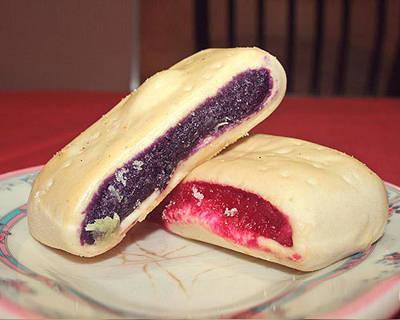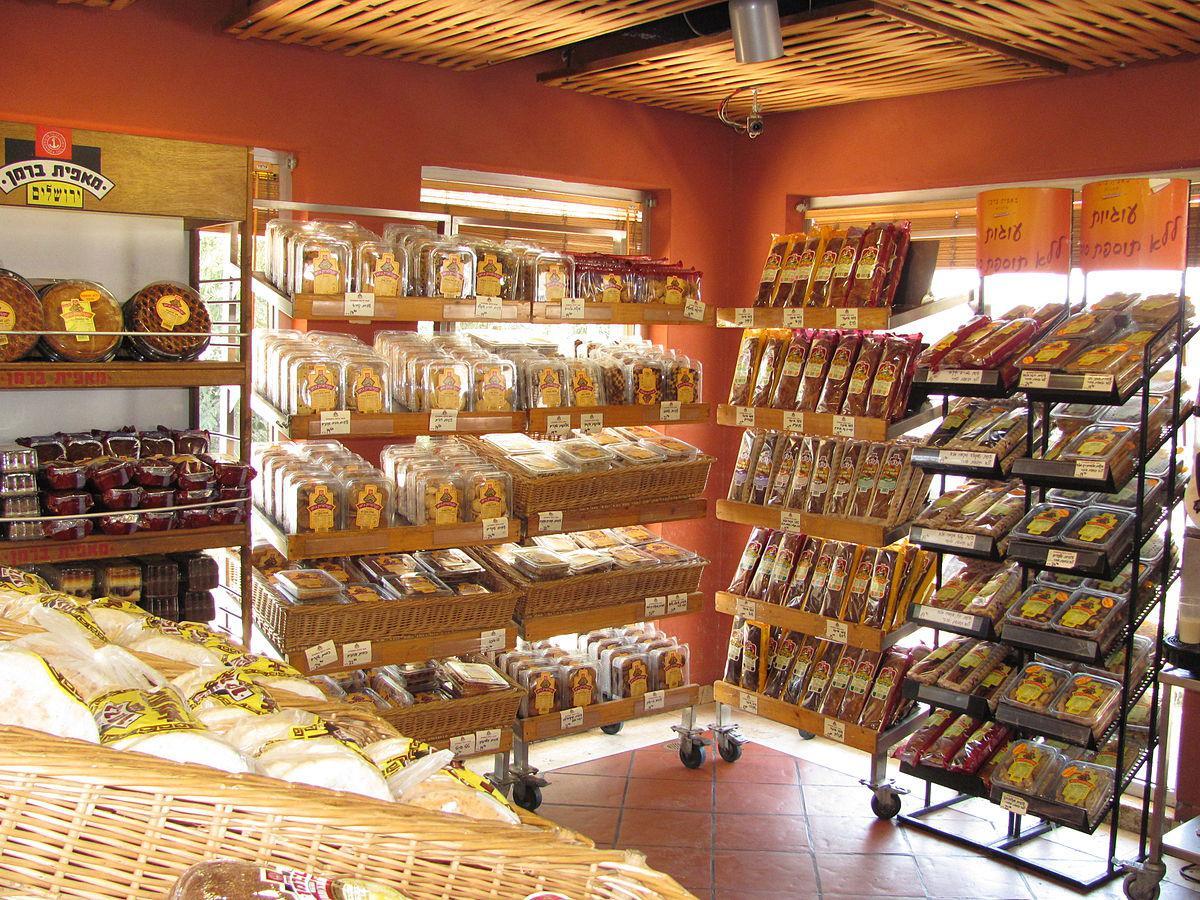The first image is the image on the left, the second image is the image on the right. For the images displayed, is the sentence "There are windows in one of the images." factually correct? Answer yes or no. Yes. 